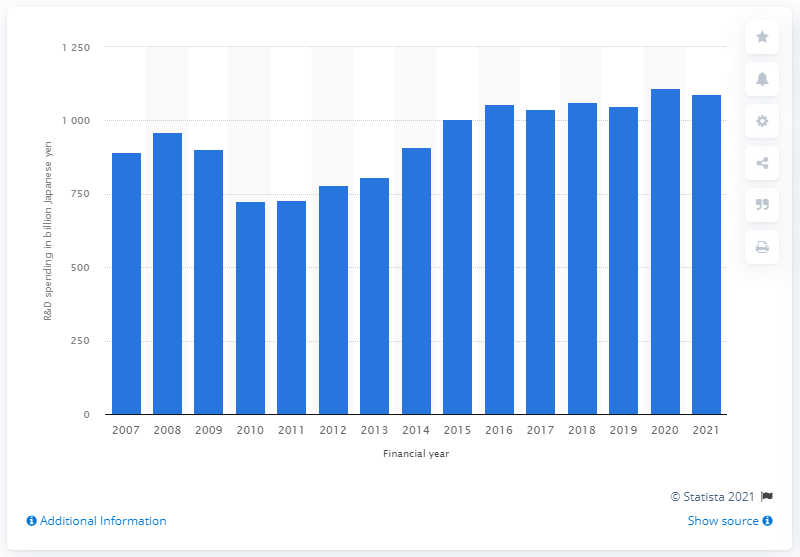Highlight a few significant elements in this photo. Toyota's research and development expenses in yen amounted to 1090.4 billion in the given year. 